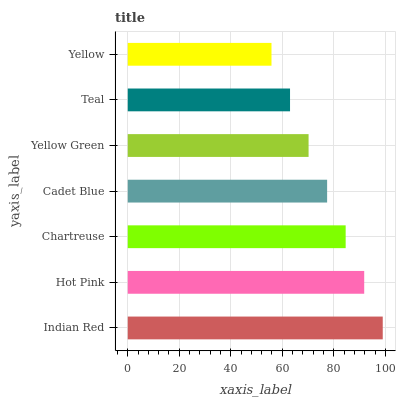Is Yellow the minimum?
Answer yes or no. Yes. Is Indian Red the maximum?
Answer yes or no. Yes. Is Hot Pink the minimum?
Answer yes or no. No. Is Hot Pink the maximum?
Answer yes or no. No. Is Indian Red greater than Hot Pink?
Answer yes or no. Yes. Is Hot Pink less than Indian Red?
Answer yes or no. Yes. Is Hot Pink greater than Indian Red?
Answer yes or no. No. Is Indian Red less than Hot Pink?
Answer yes or no. No. Is Cadet Blue the high median?
Answer yes or no. Yes. Is Cadet Blue the low median?
Answer yes or no. Yes. Is Yellow Green the high median?
Answer yes or no. No. Is Yellow the low median?
Answer yes or no. No. 